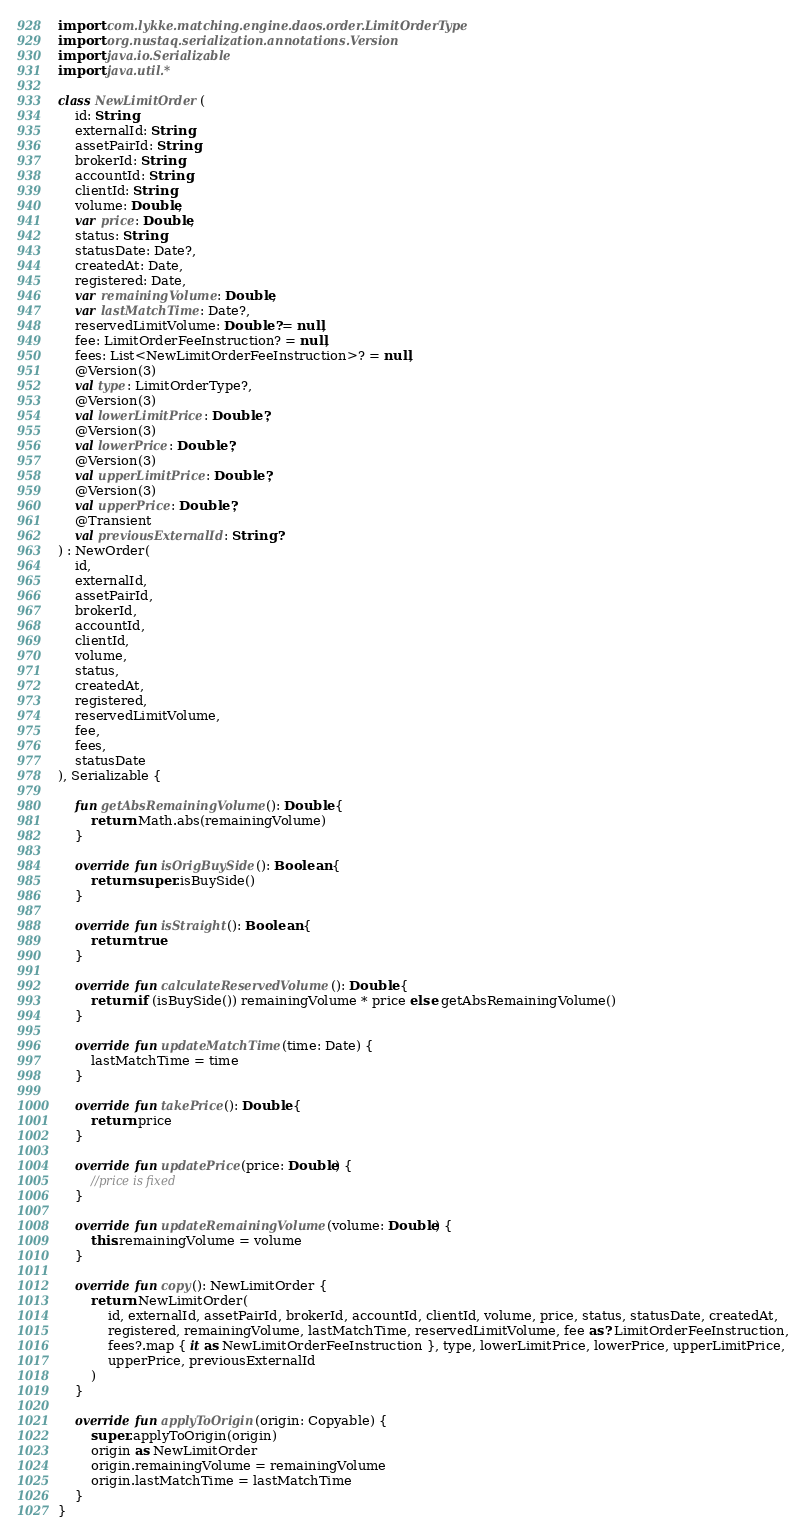Convert code to text. <code><loc_0><loc_0><loc_500><loc_500><_Kotlin_>import com.lykke.matching.engine.daos.order.LimitOrderType
import org.nustaq.serialization.annotations.Version
import java.io.Serializable
import java.util.*

class NewLimitOrder(
    id: String,
    externalId: String,
    assetPairId: String,
    brokerId: String,
    accountId: String,
    clientId: String,
    volume: Double,
    var price: Double,
    status: String,
    statusDate: Date?,
    createdAt: Date,
    registered: Date,
    var remainingVolume: Double,
    var lastMatchTime: Date?,
    reservedLimitVolume: Double? = null,
    fee: LimitOrderFeeInstruction? = null,
    fees: List<NewLimitOrderFeeInstruction>? = null,
    @Version(3)
    val type: LimitOrderType?,
    @Version(3)
    val lowerLimitPrice: Double?,
    @Version(3)
    val lowerPrice: Double?,
    @Version(3)
    val upperLimitPrice: Double?,
    @Version(3)
    val upperPrice: Double?,
    @Transient
    val previousExternalId: String?
) : NewOrder(
    id,
    externalId,
    assetPairId,
    brokerId,
    accountId,
    clientId,
    volume,
    status,
    createdAt,
    registered,
    reservedLimitVolume,
    fee,
    fees,
    statusDate
), Serializable {

    fun getAbsRemainingVolume(): Double {
        return Math.abs(remainingVolume)
    }

    override fun isOrigBuySide(): Boolean {
        return super.isBuySide()
    }

    override fun isStraight(): Boolean {
        return true
    }

    override fun calculateReservedVolume(): Double {
        return if (isBuySide()) remainingVolume * price else getAbsRemainingVolume()
    }

    override fun updateMatchTime(time: Date) {
        lastMatchTime = time
    }

    override fun takePrice(): Double {
        return price
    }

    override fun updatePrice(price: Double) {
        //price is fixed
    }

    override fun updateRemainingVolume(volume: Double) {
        this.remainingVolume = volume
    }

    override fun copy(): NewLimitOrder {
        return NewLimitOrder(
            id, externalId, assetPairId, brokerId, accountId, clientId, volume, price, status, statusDate, createdAt,
            registered, remainingVolume, lastMatchTime, reservedLimitVolume, fee as? LimitOrderFeeInstruction,
            fees?.map { it as NewLimitOrderFeeInstruction }, type, lowerLimitPrice, lowerPrice, upperLimitPrice,
            upperPrice, previousExternalId
        )
    }

    override fun applyToOrigin(origin: Copyable) {
        super.applyToOrigin(origin)
        origin as NewLimitOrder
        origin.remainingVolume = remainingVolume
        origin.lastMatchTime = lastMatchTime
    }
}</code> 